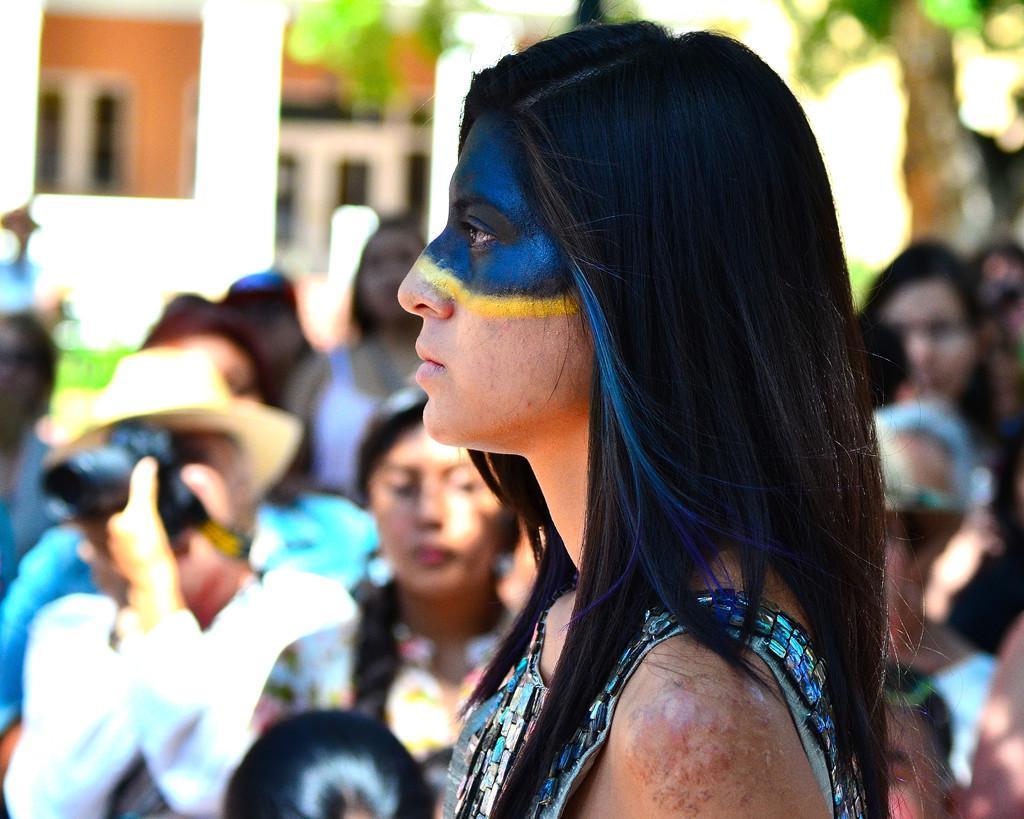Describe this image in one or two sentences. In this image we can see some group of persons standing, in the foreground of the image there is a lady person applied some paint and in the background of the image there is a wall and tree. 